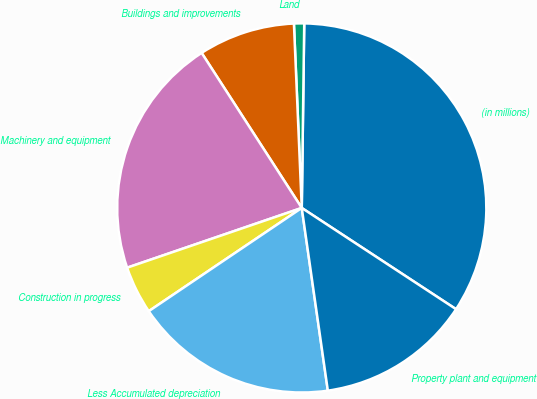Convert chart. <chart><loc_0><loc_0><loc_500><loc_500><pie_chart><fcel>(in millions)<fcel>Land<fcel>Buildings and improvements<fcel>Machinery and equipment<fcel>Construction in progress<fcel>Less Accumulated depreciation<fcel>Property plant and equipment<nl><fcel>34.03%<fcel>0.89%<fcel>8.45%<fcel>21.12%<fcel>4.2%<fcel>17.81%<fcel>13.5%<nl></chart> 